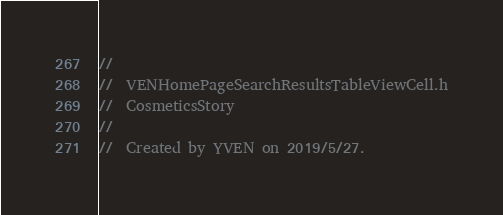<code> <loc_0><loc_0><loc_500><loc_500><_C_>//
//  VENHomePageSearchResultsTableViewCell.h
//  CosmeticsStory
//
//  Created by YVEN on 2019/5/27.</code> 